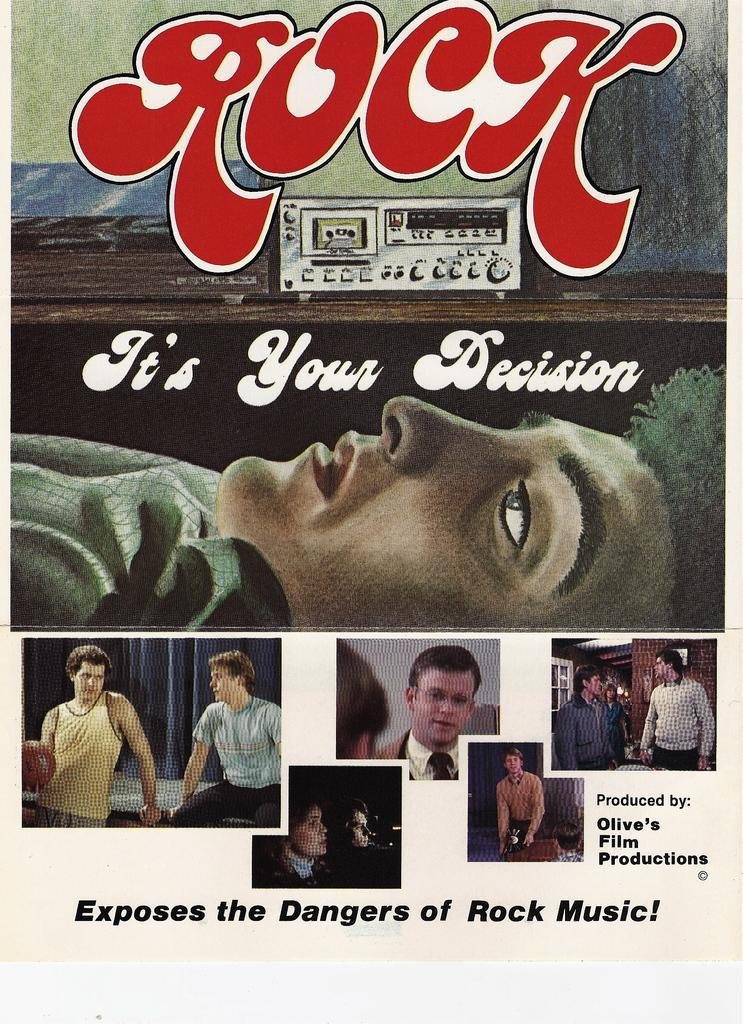What is the main subject of the image? There is a picture of a person in the image. What other object can be seen in the image? There is a tape recorder in the image. What is written or depicted at the bottom of the image? There is text and pictures at the bottom of the image. How many cattle are visible in the image? There are no cattle present in the image. What type of sock is the person wearing in the image? The image does not show the person's feet or any socks. 